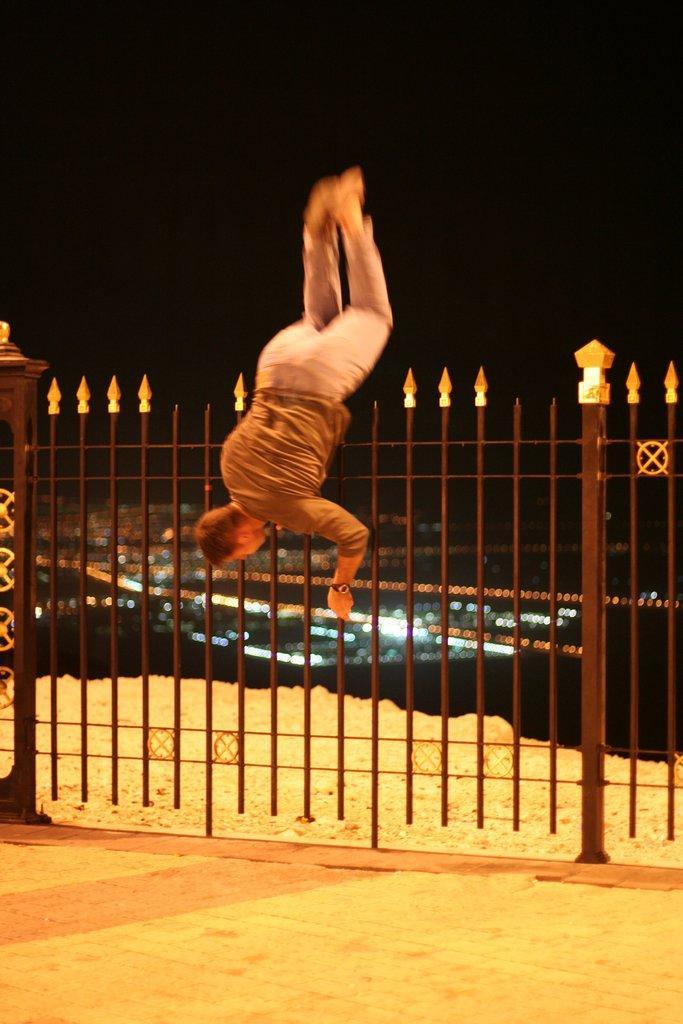How would you summarize this image in a sentence or two? In the foreground of the image we can see sand. In the middle of the image we can see iron rods and a man is doing stunts. On the top of the image we can see the darkness. 